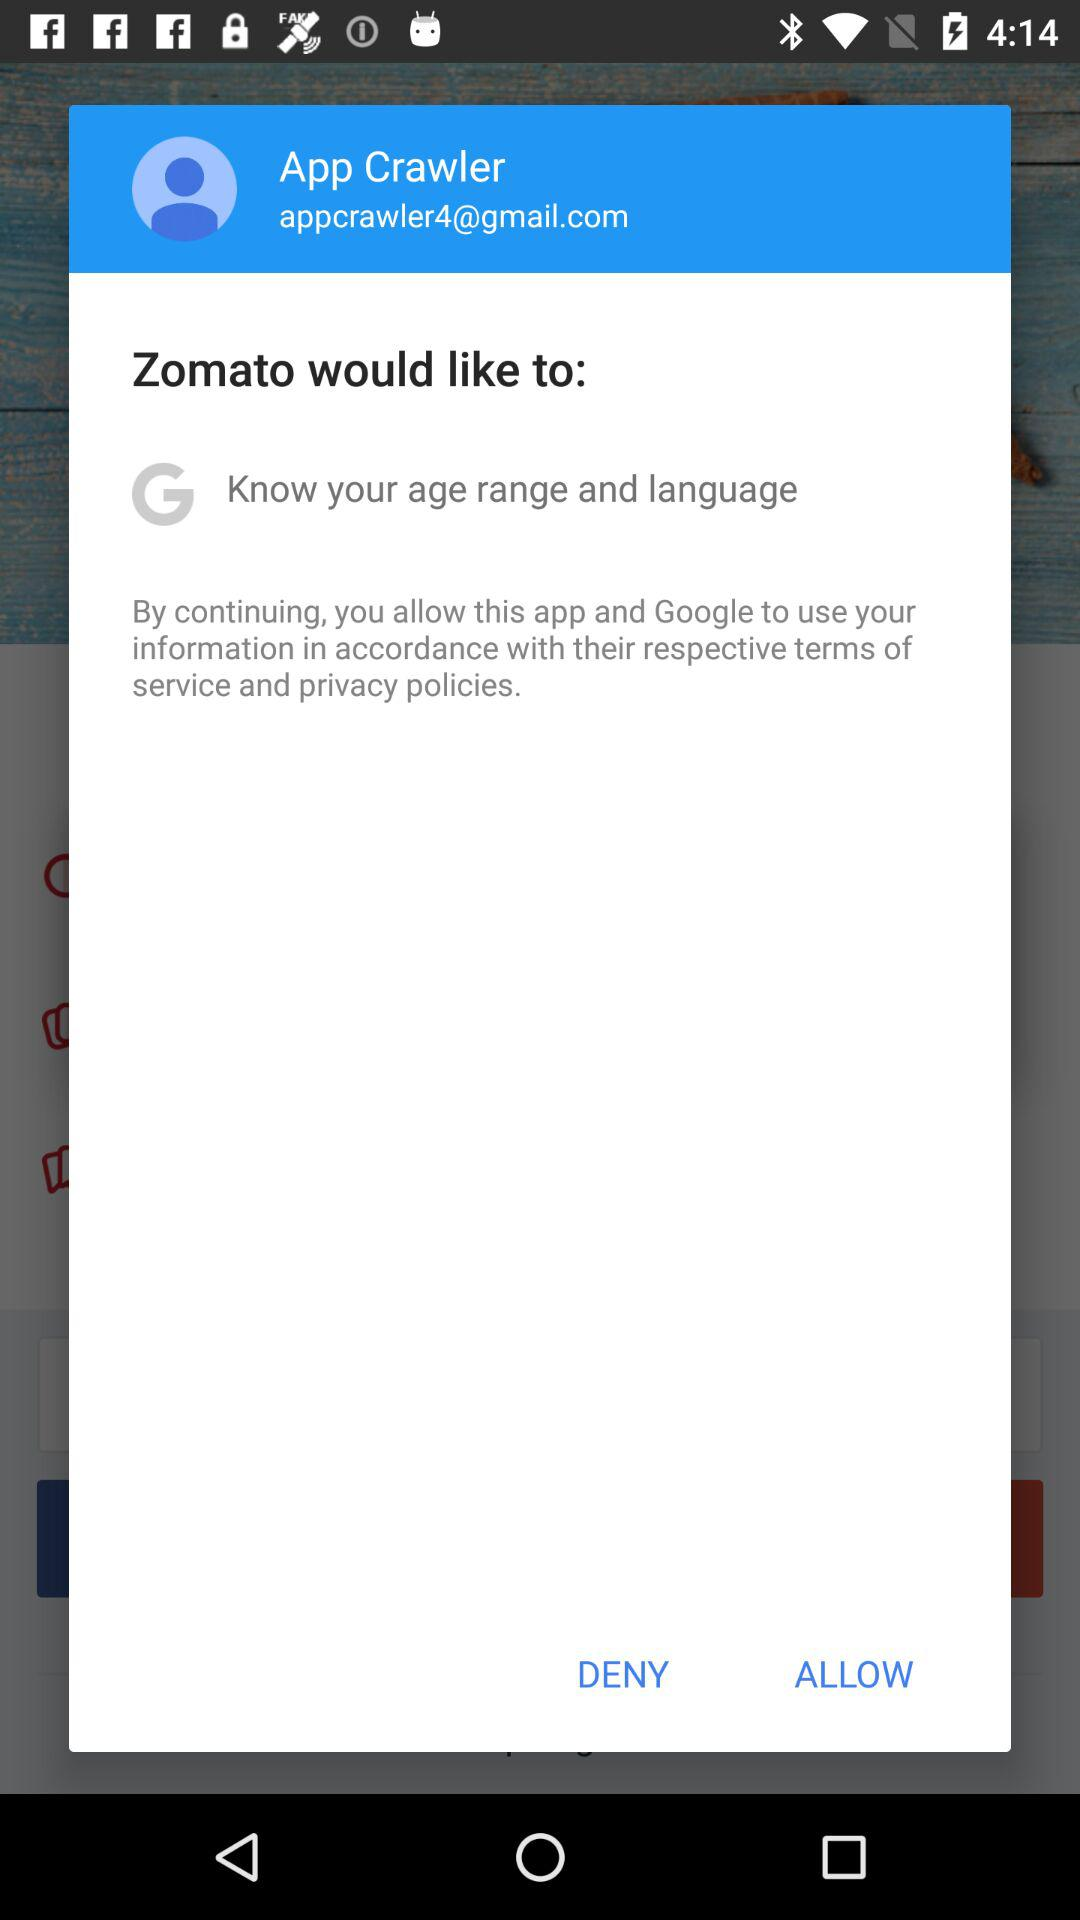What is the user's name? The user's name is App Crawler. 